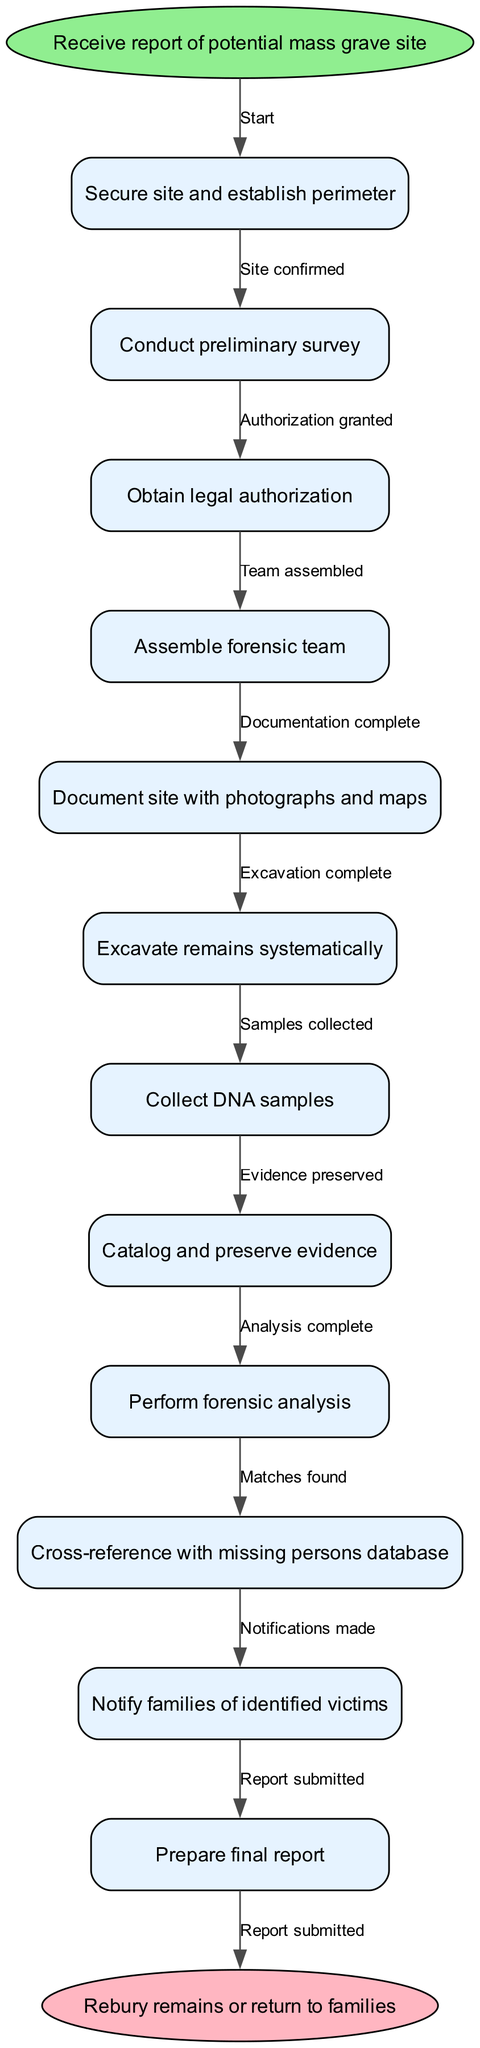What is the starting point of the procedure? The starting point of the procedure is "Receive report of potential mass grave site," located at the start node of the diagram.
Answer: Receive report of potential mass grave site How many total nodes are in the diagram? The total number of nodes includes the start node, all process nodes, and the end node. There are 12 nodes in total (1 start + 10 process + 1 end).
Answer: 12 What is the last action in the exhumation process? The last action shown in the diagram is "Prepare final report," which is the last process node before moving to the end.
Answer: Prepare final report What is the first action taken after securing the site? After securing the site, the next action taken is "Conduct preliminary survey," as represented in the flow of the diagram.
Answer: Conduct preliminary survey What documentation is completed before excavation? The documentation completed before excavation consists of "Document site with photographs and maps," which is a necessary step in the procedure.
Answer: Document site with photographs and maps What is the final step after notifying families of identified victims? The final step following the notification of families is "Rebury remains or return to families," which represents the end of the process.
Answer: Rebury remains or return to families What is required before assembling the forensic team? Before the forensic team can be assembled, "Obtain legal authorization" is required as indicated in the flow of the procedure.
Answer: Obtain legal authorization How many edges connect the nodes in the diagram? The number of edges in the diagram is equal to the number of transitions between the nodes. There are 11 edges connecting the 12 nodes.
Answer: 11 What action follows the excavation of remains? Following the excavation of remains, the subsequent action is "Collect DNA samples," which is the next logical step in the process flow.
Answer: Collect DNA samples What relationship exists between "Cross-reference with missing persons database" and "Notify families of identified victims"? The relationship is that "Cross-reference with missing persons database" precedes "Notify families of identified victims," indicating that families are notified only after cross-referencing the data.
Answer: Precedes 